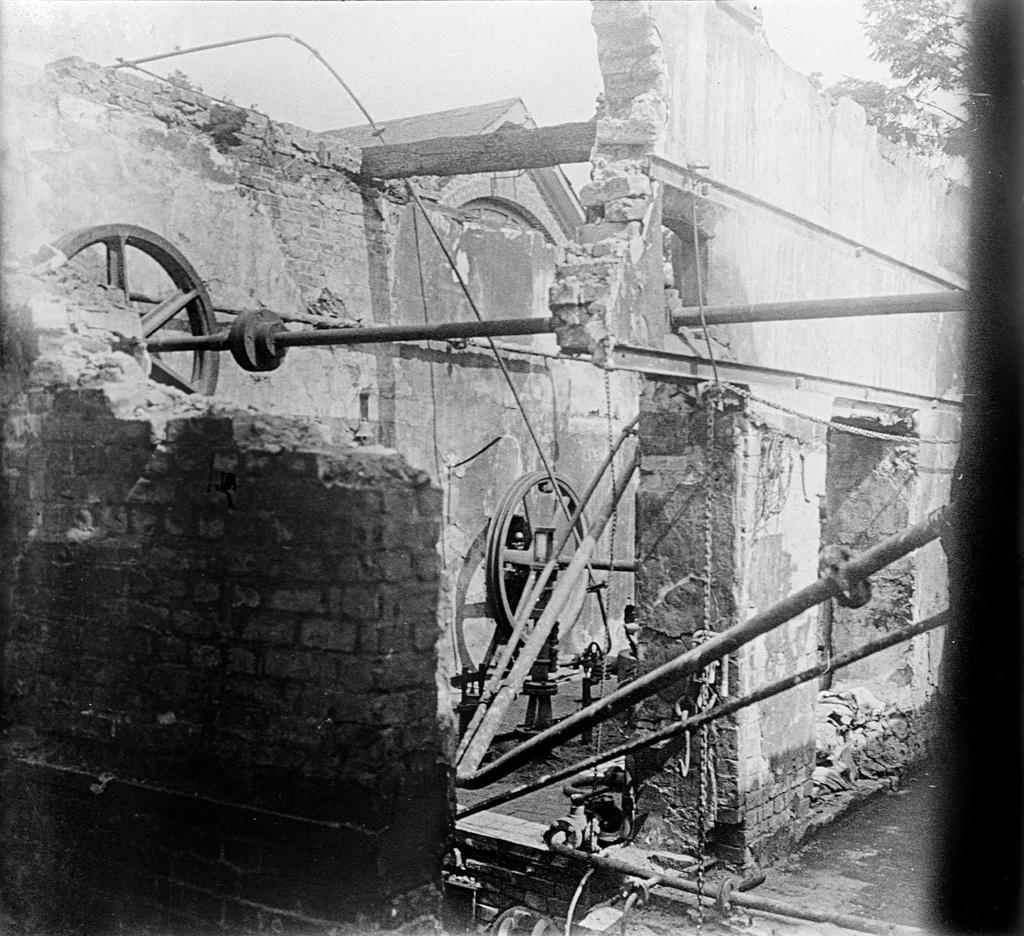Can you describe this image briefly? In this picture we can see the walls, wheels, rods and some objects and in the background we can see leaves. 